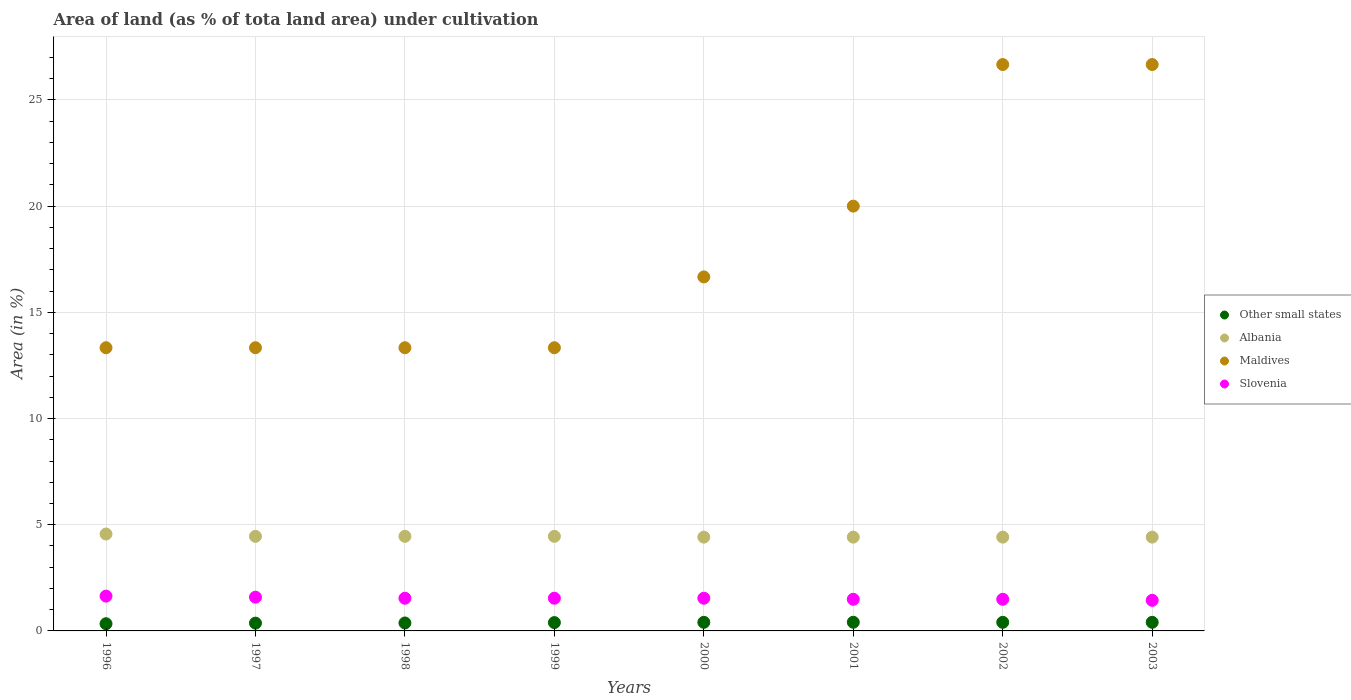Is the number of dotlines equal to the number of legend labels?
Provide a succinct answer. Yes. What is the percentage of land under cultivation in Albania in 1998?
Keep it short and to the point. 4.45. Across all years, what is the maximum percentage of land under cultivation in Slovenia?
Offer a very short reply. 1.64. Across all years, what is the minimum percentage of land under cultivation in Maldives?
Your answer should be compact. 13.33. In which year was the percentage of land under cultivation in Slovenia maximum?
Make the answer very short. 1996. In which year was the percentage of land under cultivation in Slovenia minimum?
Your answer should be very brief. 2003. What is the total percentage of land under cultivation in Maldives in the graph?
Make the answer very short. 143.33. What is the difference between the percentage of land under cultivation in Maldives in 2002 and the percentage of land under cultivation in Albania in 2001?
Make the answer very short. 22.25. What is the average percentage of land under cultivation in Albania per year?
Your answer should be very brief. 4.45. In the year 2003, what is the difference between the percentage of land under cultivation in Albania and percentage of land under cultivation in Other small states?
Give a very brief answer. 4.01. In how many years, is the percentage of land under cultivation in Other small states greater than 13 %?
Offer a very short reply. 0. What is the ratio of the percentage of land under cultivation in Maldives in 2000 to that in 2002?
Keep it short and to the point. 0.63. Is the difference between the percentage of land under cultivation in Albania in 1996 and 2003 greater than the difference between the percentage of land under cultivation in Other small states in 1996 and 2003?
Offer a very short reply. Yes. What is the difference between the highest and the second highest percentage of land under cultivation in Maldives?
Provide a succinct answer. 0. What is the difference between the highest and the lowest percentage of land under cultivation in Slovenia?
Give a very brief answer. 0.2. In how many years, is the percentage of land under cultivation in Maldives greater than the average percentage of land under cultivation in Maldives taken over all years?
Offer a very short reply. 3. Is it the case that in every year, the sum of the percentage of land under cultivation in Other small states and percentage of land under cultivation in Maldives  is greater than the sum of percentage of land under cultivation in Albania and percentage of land under cultivation in Slovenia?
Keep it short and to the point. Yes. Is the percentage of land under cultivation in Other small states strictly less than the percentage of land under cultivation in Maldives over the years?
Offer a terse response. Yes. What is the difference between two consecutive major ticks on the Y-axis?
Ensure brevity in your answer.  5. How many legend labels are there?
Your answer should be compact. 4. What is the title of the graph?
Your response must be concise. Area of land (as % of tota land area) under cultivation. What is the label or title of the Y-axis?
Keep it short and to the point. Area (in %). What is the Area (in %) of Other small states in 1996?
Your answer should be very brief. 0.34. What is the Area (in %) in Albania in 1996?
Offer a very short reply. 4.56. What is the Area (in %) of Maldives in 1996?
Provide a succinct answer. 13.33. What is the Area (in %) in Slovenia in 1996?
Keep it short and to the point. 1.64. What is the Area (in %) in Other small states in 1997?
Provide a succinct answer. 0.37. What is the Area (in %) of Albania in 1997?
Make the answer very short. 4.45. What is the Area (in %) in Maldives in 1997?
Give a very brief answer. 13.33. What is the Area (in %) in Slovenia in 1997?
Make the answer very short. 1.59. What is the Area (in %) of Other small states in 1998?
Keep it short and to the point. 0.37. What is the Area (in %) in Albania in 1998?
Make the answer very short. 4.45. What is the Area (in %) of Maldives in 1998?
Provide a succinct answer. 13.33. What is the Area (in %) in Slovenia in 1998?
Your response must be concise. 1.54. What is the Area (in %) in Other small states in 1999?
Your response must be concise. 0.39. What is the Area (in %) of Albania in 1999?
Keep it short and to the point. 4.45. What is the Area (in %) of Maldives in 1999?
Your response must be concise. 13.33. What is the Area (in %) in Slovenia in 1999?
Ensure brevity in your answer.  1.54. What is the Area (in %) in Other small states in 2000?
Your answer should be compact. 0.41. What is the Area (in %) in Albania in 2000?
Provide a short and direct response. 4.42. What is the Area (in %) in Maldives in 2000?
Give a very brief answer. 16.67. What is the Area (in %) in Slovenia in 2000?
Your answer should be compact. 1.54. What is the Area (in %) in Other small states in 2001?
Your answer should be compact. 0.41. What is the Area (in %) in Albania in 2001?
Make the answer very short. 4.42. What is the Area (in %) of Maldives in 2001?
Ensure brevity in your answer.  20. What is the Area (in %) in Slovenia in 2001?
Provide a short and direct response. 1.49. What is the Area (in %) of Other small states in 2002?
Give a very brief answer. 0.4. What is the Area (in %) of Albania in 2002?
Your answer should be compact. 4.42. What is the Area (in %) in Maldives in 2002?
Make the answer very short. 26.67. What is the Area (in %) of Slovenia in 2002?
Offer a very short reply. 1.49. What is the Area (in %) in Other small states in 2003?
Your response must be concise. 0.41. What is the Area (in %) in Albania in 2003?
Provide a short and direct response. 4.42. What is the Area (in %) in Maldives in 2003?
Provide a succinct answer. 26.67. What is the Area (in %) of Slovenia in 2003?
Provide a succinct answer. 1.44. Across all years, what is the maximum Area (in %) of Other small states?
Offer a terse response. 0.41. Across all years, what is the maximum Area (in %) of Albania?
Keep it short and to the point. 4.56. Across all years, what is the maximum Area (in %) in Maldives?
Your response must be concise. 26.67. Across all years, what is the maximum Area (in %) of Slovenia?
Ensure brevity in your answer.  1.64. Across all years, what is the minimum Area (in %) of Other small states?
Ensure brevity in your answer.  0.34. Across all years, what is the minimum Area (in %) in Albania?
Provide a short and direct response. 4.42. Across all years, what is the minimum Area (in %) in Maldives?
Offer a very short reply. 13.33. Across all years, what is the minimum Area (in %) of Slovenia?
Your response must be concise. 1.44. What is the total Area (in %) in Other small states in the graph?
Provide a short and direct response. 3.09. What is the total Area (in %) of Albania in the graph?
Ensure brevity in your answer.  35.58. What is the total Area (in %) in Maldives in the graph?
Make the answer very short. 143.33. What is the total Area (in %) of Slovenia in the graph?
Offer a very short reply. 12.26. What is the difference between the Area (in %) in Other small states in 1996 and that in 1997?
Provide a succinct answer. -0.03. What is the difference between the Area (in %) in Albania in 1996 and that in 1997?
Your answer should be compact. 0.11. What is the difference between the Area (in %) in Slovenia in 1996 and that in 1997?
Provide a short and direct response. 0.05. What is the difference between the Area (in %) in Other small states in 1996 and that in 1998?
Provide a succinct answer. -0.04. What is the difference between the Area (in %) of Albania in 1996 and that in 1998?
Provide a succinct answer. 0.11. What is the difference between the Area (in %) of Maldives in 1996 and that in 1998?
Your answer should be very brief. 0. What is the difference between the Area (in %) in Slovenia in 1996 and that in 1998?
Your answer should be compact. 0.1. What is the difference between the Area (in %) in Other small states in 1996 and that in 1999?
Provide a succinct answer. -0.05. What is the difference between the Area (in %) in Albania in 1996 and that in 1999?
Your answer should be compact. 0.11. What is the difference between the Area (in %) in Maldives in 1996 and that in 1999?
Keep it short and to the point. 0. What is the difference between the Area (in %) in Slovenia in 1996 and that in 1999?
Make the answer very short. 0.1. What is the difference between the Area (in %) in Other small states in 1996 and that in 2000?
Keep it short and to the point. -0.07. What is the difference between the Area (in %) of Albania in 1996 and that in 2000?
Make the answer very short. 0.15. What is the difference between the Area (in %) in Maldives in 1996 and that in 2000?
Your answer should be very brief. -3.33. What is the difference between the Area (in %) of Slovenia in 1996 and that in 2000?
Offer a very short reply. 0.1. What is the difference between the Area (in %) in Other small states in 1996 and that in 2001?
Offer a terse response. -0.07. What is the difference between the Area (in %) of Albania in 1996 and that in 2001?
Make the answer very short. 0.15. What is the difference between the Area (in %) of Maldives in 1996 and that in 2001?
Your answer should be compact. -6.67. What is the difference between the Area (in %) of Slovenia in 1996 and that in 2001?
Offer a very short reply. 0.15. What is the difference between the Area (in %) of Other small states in 1996 and that in 2002?
Offer a very short reply. -0.07. What is the difference between the Area (in %) in Albania in 1996 and that in 2002?
Offer a terse response. 0.15. What is the difference between the Area (in %) of Maldives in 1996 and that in 2002?
Your answer should be compact. -13.33. What is the difference between the Area (in %) in Slovenia in 1996 and that in 2002?
Give a very brief answer. 0.15. What is the difference between the Area (in %) in Other small states in 1996 and that in 2003?
Your response must be concise. -0.07. What is the difference between the Area (in %) of Albania in 1996 and that in 2003?
Your answer should be compact. 0.15. What is the difference between the Area (in %) in Maldives in 1996 and that in 2003?
Your answer should be compact. -13.33. What is the difference between the Area (in %) in Slovenia in 1996 and that in 2003?
Your answer should be compact. 0.2. What is the difference between the Area (in %) in Other small states in 1997 and that in 1998?
Your answer should be very brief. -0.01. What is the difference between the Area (in %) of Albania in 1997 and that in 1998?
Make the answer very short. 0. What is the difference between the Area (in %) of Maldives in 1997 and that in 1998?
Your response must be concise. 0. What is the difference between the Area (in %) of Slovenia in 1997 and that in 1998?
Give a very brief answer. 0.05. What is the difference between the Area (in %) of Other small states in 1997 and that in 1999?
Provide a succinct answer. -0.03. What is the difference between the Area (in %) in Albania in 1997 and that in 1999?
Make the answer very short. 0. What is the difference between the Area (in %) in Maldives in 1997 and that in 1999?
Your response must be concise. 0. What is the difference between the Area (in %) of Slovenia in 1997 and that in 1999?
Ensure brevity in your answer.  0.05. What is the difference between the Area (in %) of Other small states in 1997 and that in 2000?
Give a very brief answer. -0.04. What is the difference between the Area (in %) in Albania in 1997 and that in 2000?
Your response must be concise. 0.04. What is the difference between the Area (in %) of Maldives in 1997 and that in 2000?
Your answer should be very brief. -3.33. What is the difference between the Area (in %) in Slovenia in 1997 and that in 2000?
Your answer should be very brief. 0.05. What is the difference between the Area (in %) in Other small states in 1997 and that in 2001?
Your response must be concise. -0.04. What is the difference between the Area (in %) of Albania in 1997 and that in 2001?
Your answer should be very brief. 0.04. What is the difference between the Area (in %) in Maldives in 1997 and that in 2001?
Offer a terse response. -6.67. What is the difference between the Area (in %) of Slovenia in 1997 and that in 2001?
Your answer should be very brief. 0.1. What is the difference between the Area (in %) in Other small states in 1997 and that in 2002?
Provide a succinct answer. -0.04. What is the difference between the Area (in %) in Albania in 1997 and that in 2002?
Ensure brevity in your answer.  0.04. What is the difference between the Area (in %) in Maldives in 1997 and that in 2002?
Keep it short and to the point. -13.33. What is the difference between the Area (in %) in Slovenia in 1997 and that in 2002?
Ensure brevity in your answer.  0.1. What is the difference between the Area (in %) of Other small states in 1997 and that in 2003?
Your answer should be compact. -0.04. What is the difference between the Area (in %) of Albania in 1997 and that in 2003?
Ensure brevity in your answer.  0.04. What is the difference between the Area (in %) in Maldives in 1997 and that in 2003?
Your response must be concise. -13.33. What is the difference between the Area (in %) of Slovenia in 1997 and that in 2003?
Your answer should be very brief. 0.15. What is the difference between the Area (in %) of Other small states in 1998 and that in 1999?
Provide a short and direct response. -0.02. What is the difference between the Area (in %) in Albania in 1998 and that in 1999?
Your answer should be compact. 0. What is the difference between the Area (in %) in Slovenia in 1998 and that in 1999?
Your answer should be compact. 0. What is the difference between the Area (in %) in Other small states in 1998 and that in 2000?
Make the answer very short. -0.03. What is the difference between the Area (in %) in Albania in 1998 and that in 2000?
Offer a very short reply. 0.04. What is the difference between the Area (in %) in Other small states in 1998 and that in 2001?
Provide a succinct answer. -0.03. What is the difference between the Area (in %) of Albania in 1998 and that in 2001?
Provide a succinct answer. 0.04. What is the difference between the Area (in %) of Maldives in 1998 and that in 2001?
Offer a terse response. -6.67. What is the difference between the Area (in %) of Slovenia in 1998 and that in 2001?
Make the answer very short. 0.05. What is the difference between the Area (in %) in Other small states in 1998 and that in 2002?
Your response must be concise. -0.03. What is the difference between the Area (in %) in Albania in 1998 and that in 2002?
Keep it short and to the point. 0.04. What is the difference between the Area (in %) of Maldives in 1998 and that in 2002?
Your response must be concise. -13.33. What is the difference between the Area (in %) in Slovenia in 1998 and that in 2002?
Offer a very short reply. 0.05. What is the difference between the Area (in %) in Other small states in 1998 and that in 2003?
Your response must be concise. -0.03. What is the difference between the Area (in %) of Albania in 1998 and that in 2003?
Make the answer very short. 0.04. What is the difference between the Area (in %) in Maldives in 1998 and that in 2003?
Make the answer very short. -13.33. What is the difference between the Area (in %) in Slovenia in 1998 and that in 2003?
Ensure brevity in your answer.  0.1. What is the difference between the Area (in %) of Other small states in 1999 and that in 2000?
Provide a short and direct response. -0.01. What is the difference between the Area (in %) in Albania in 1999 and that in 2000?
Your answer should be very brief. 0.04. What is the difference between the Area (in %) in Maldives in 1999 and that in 2000?
Your answer should be compact. -3.33. What is the difference between the Area (in %) in Slovenia in 1999 and that in 2000?
Ensure brevity in your answer.  0. What is the difference between the Area (in %) in Other small states in 1999 and that in 2001?
Provide a succinct answer. -0.02. What is the difference between the Area (in %) of Albania in 1999 and that in 2001?
Make the answer very short. 0.04. What is the difference between the Area (in %) in Maldives in 1999 and that in 2001?
Offer a very short reply. -6.67. What is the difference between the Area (in %) of Slovenia in 1999 and that in 2001?
Offer a very short reply. 0.05. What is the difference between the Area (in %) of Other small states in 1999 and that in 2002?
Offer a terse response. -0.01. What is the difference between the Area (in %) of Albania in 1999 and that in 2002?
Give a very brief answer. 0.04. What is the difference between the Area (in %) of Maldives in 1999 and that in 2002?
Offer a very short reply. -13.33. What is the difference between the Area (in %) of Slovenia in 1999 and that in 2002?
Keep it short and to the point. 0.05. What is the difference between the Area (in %) of Other small states in 1999 and that in 2003?
Your answer should be compact. -0.01. What is the difference between the Area (in %) in Albania in 1999 and that in 2003?
Your answer should be very brief. 0.04. What is the difference between the Area (in %) of Maldives in 1999 and that in 2003?
Your response must be concise. -13.33. What is the difference between the Area (in %) in Slovenia in 1999 and that in 2003?
Make the answer very short. 0.1. What is the difference between the Area (in %) of Other small states in 2000 and that in 2001?
Offer a very short reply. -0. What is the difference between the Area (in %) in Albania in 2000 and that in 2001?
Provide a succinct answer. 0. What is the difference between the Area (in %) of Slovenia in 2000 and that in 2001?
Your response must be concise. 0.05. What is the difference between the Area (in %) of Other small states in 2000 and that in 2002?
Provide a succinct answer. 0. What is the difference between the Area (in %) in Maldives in 2000 and that in 2002?
Make the answer very short. -10. What is the difference between the Area (in %) of Slovenia in 2000 and that in 2002?
Your answer should be very brief. 0.05. What is the difference between the Area (in %) of Slovenia in 2000 and that in 2003?
Keep it short and to the point. 0.1. What is the difference between the Area (in %) in Other small states in 2001 and that in 2002?
Provide a succinct answer. 0. What is the difference between the Area (in %) in Albania in 2001 and that in 2002?
Make the answer very short. 0. What is the difference between the Area (in %) in Maldives in 2001 and that in 2002?
Your answer should be very brief. -6.67. What is the difference between the Area (in %) in Other small states in 2001 and that in 2003?
Keep it short and to the point. 0. What is the difference between the Area (in %) of Maldives in 2001 and that in 2003?
Offer a very short reply. -6.67. What is the difference between the Area (in %) in Slovenia in 2001 and that in 2003?
Your answer should be compact. 0.05. What is the difference between the Area (in %) in Other small states in 2002 and that in 2003?
Your response must be concise. -0. What is the difference between the Area (in %) of Slovenia in 2002 and that in 2003?
Offer a very short reply. 0.05. What is the difference between the Area (in %) of Other small states in 1996 and the Area (in %) of Albania in 1997?
Offer a terse response. -4.11. What is the difference between the Area (in %) of Other small states in 1996 and the Area (in %) of Maldives in 1997?
Your answer should be very brief. -12.99. What is the difference between the Area (in %) in Other small states in 1996 and the Area (in %) in Slovenia in 1997?
Keep it short and to the point. -1.25. What is the difference between the Area (in %) in Albania in 1996 and the Area (in %) in Maldives in 1997?
Your answer should be compact. -8.77. What is the difference between the Area (in %) in Albania in 1996 and the Area (in %) in Slovenia in 1997?
Give a very brief answer. 2.97. What is the difference between the Area (in %) in Maldives in 1996 and the Area (in %) in Slovenia in 1997?
Make the answer very short. 11.74. What is the difference between the Area (in %) in Other small states in 1996 and the Area (in %) in Albania in 1998?
Provide a succinct answer. -4.11. What is the difference between the Area (in %) in Other small states in 1996 and the Area (in %) in Maldives in 1998?
Ensure brevity in your answer.  -12.99. What is the difference between the Area (in %) of Other small states in 1996 and the Area (in %) of Slovenia in 1998?
Offer a terse response. -1.2. What is the difference between the Area (in %) in Albania in 1996 and the Area (in %) in Maldives in 1998?
Keep it short and to the point. -8.77. What is the difference between the Area (in %) in Albania in 1996 and the Area (in %) in Slovenia in 1998?
Give a very brief answer. 3.02. What is the difference between the Area (in %) in Maldives in 1996 and the Area (in %) in Slovenia in 1998?
Offer a very short reply. 11.79. What is the difference between the Area (in %) in Other small states in 1996 and the Area (in %) in Albania in 1999?
Offer a terse response. -4.11. What is the difference between the Area (in %) of Other small states in 1996 and the Area (in %) of Maldives in 1999?
Provide a succinct answer. -12.99. What is the difference between the Area (in %) of Other small states in 1996 and the Area (in %) of Slovenia in 1999?
Offer a terse response. -1.2. What is the difference between the Area (in %) of Albania in 1996 and the Area (in %) of Maldives in 1999?
Provide a short and direct response. -8.77. What is the difference between the Area (in %) in Albania in 1996 and the Area (in %) in Slovenia in 1999?
Provide a succinct answer. 3.02. What is the difference between the Area (in %) of Maldives in 1996 and the Area (in %) of Slovenia in 1999?
Keep it short and to the point. 11.79. What is the difference between the Area (in %) in Other small states in 1996 and the Area (in %) in Albania in 2000?
Keep it short and to the point. -4.08. What is the difference between the Area (in %) of Other small states in 1996 and the Area (in %) of Maldives in 2000?
Your response must be concise. -16.33. What is the difference between the Area (in %) in Other small states in 1996 and the Area (in %) in Slovenia in 2000?
Offer a terse response. -1.2. What is the difference between the Area (in %) in Albania in 1996 and the Area (in %) in Maldives in 2000?
Ensure brevity in your answer.  -12.1. What is the difference between the Area (in %) of Albania in 1996 and the Area (in %) of Slovenia in 2000?
Give a very brief answer. 3.02. What is the difference between the Area (in %) in Maldives in 1996 and the Area (in %) in Slovenia in 2000?
Offer a terse response. 11.79. What is the difference between the Area (in %) of Other small states in 1996 and the Area (in %) of Albania in 2001?
Make the answer very short. -4.08. What is the difference between the Area (in %) of Other small states in 1996 and the Area (in %) of Maldives in 2001?
Offer a terse response. -19.66. What is the difference between the Area (in %) in Other small states in 1996 and the Area (in %) in Slovenia in 2001?
Your response must be concise. -1.15. What is the difference between the Area (in %) in Albania in 1996 and the Area (in %) in Maldives in 2001?
Give a very brief answer. -15.44. What is the difference between the Area (in %) in Albania in 1996 and the Area (in %) in Slovenia in 2001?
Make the answer very short. 3.07. What is the difference between the Area (in %) in Maldives in 1996 and the Area (in %) in Slovenia in 2001?
Your response must be concise. 11.84. What is the difference between the Area (in %) of Other small states in 1996 and the Area (in %) of Albania in 2002?
Your response must be concise. -4.08. What is the difference between the Area (in %) of Other small states in 1996 and the Area (in %) of Maldives in 2002?
Ensure brevity in your answer.  -26.33. What is the difference between the Area (in %) in Other small states in 1996 and the Area (in %) in Slovenia in 2002?
Give a very brief answer. -1.15. What is the difference between the Area (in %) of Albania in 1996 and the Area (in %) of Maldives in 2002?
Your answer should be compact. -22.1. What is the difference between the Area (in %) in Albania in 1996 and the Area (in %) in Slovenia in 2002?
Offer a very short reply. 3.07. What is the difference between the Area (in %) in Maldives in 1996 and the Area (in %) in Slovenia in 2002?
Your answer should be very brief. 11.84. What is the difference between the Area (in %) of Other small states in 1996 and the Area (in %) of Albania in 2003?
Offer a terse response. -4.08. What is the difference between the Area (in %) in Other small states in 1996 and the Area (in %) in Maldives in 2003?
Ensure brevity in your answer.  -26.33. What is the difference between the Area (in %) of Other small states in 1996 and the Area (in %) of Slovenia in 2003?
Ensure brevity in your answer.  -1.1. What is the difference between the Area (in %) in Albania in 1996 and the Area (in %) in Maldives in 2003?
Your response must be concise. -22.1. What is the difference between the Area (in %) of Albania in 1996 and the Area (in %) of Slovenia in 2003?
Offer a very short reply. 3.12. What is the difference between the Area (in %) in Maldives in 1996 and the Area (in %) in Slovenia in 2003?
Your answer should be very brief. 11.89. What is the difference between the Area (in %) in Other small states in 1997 and the Area (in %) in Albania in 1998?
Give a very brief answer. -4.09. What is the difference between the Area (in %) in Other small states in 1997 and the Area (in %) in Maldives in 1998?
Offer a very short reply. -12.97. What is the difference between the Area (in %) of Other small states in 1997 and the Area (in %) of Slovenia in 1998?
Your response must be concise. -1.17. What is the difference between the Area (in %) in Albania in 1997 and the Area (in %) in Maldives in 1998?
Give a very brief answer. -8.88. What is the difference between the Area (in %) in Albania in 1997 and the Area (in %) in Slovenia in 1998?
Provide a succinct answer. 2.91. What is the difference between the Area (in %) of Maldives in 1997 and the Area (in %) of Slovenia in 1998?
Ensure brevity in your answer.  11.79. What is the difference between the Area (in %) of Other small states in 1997 and the Area (in %) of Albania in 1999?
Your response must be concise. -4.09. What is the difference between the Area (in %) in Other small states in 1997 and the Area (in %) in Maldives in 1999?
Keep it short and to the point. -12.97. What is the difference between the Area (in %) of Other small states in 1997 and the Area (in %) of Slovenia in 1999?
Your answer should be very brief. -1.17. What is the difference between the Area (in %) in Albania in 1997 and the Area (in %) in Maldives in 1999?
Provide a short and direct response. -8.88. What is the difference between the Area (in %) of Albania in 1997 and the Area (in %) of Slovenia in 1999?
Your answer should be very brief. 2.91. What is the difference between the Area (in %) in Maldives in 1997 and the Area (in %) in Slovenia in 1999?
Offer a terse response. 11.79. What is the difference between the Area (in %) in Other small states in 1997 and the Area (in %) in Albania in 2000?
Offer a very short reply. -4.05. What is the difference between the Area (in %) of Other small states in 1997 and the Area (in %) of Maldives in 2000?
Offer a very short reply. -16.3. What is the difference between the Area (in %) in Other small states in 1997 and the Area (in %) in Slovenia in 2000?
Make the answer very short. -1.17. What is the difference between the Area (in %) in Albania in 1997 and the Area (in %) in Maldives in 2000?
Offer a terse response. -12.21. What is the difference between the Area (in %) in Albania in 1997 and the Area (in %) in Slovenia in 2000?
Give a very brief answer. 2.91. What is the difference between the Area (in %) in Maldives in 1997 and the Area (in %) in Slovenia in 2000?
Offer a very short reply. 11.79. What is the difference between the Area (in %) of Other small states in 1997 and the Area (in %) of Albania in 2001?
Offer a very short reply. -4.05. What is the difference between the Area (in %) of Other small states in 1997 and the Area (in %) of Maldives in 2001?
Offer a terse response. -19.63. What is the difference between the Area (in %) of Other small states in 1997 and the Area (in %) of Slovenia in 2001?
Make the answer very short. -1.12. What is the difference between the Area (in %) in Albania in 1997 and the Area (in %) in Maldives in 2001?
Offer a very short reply. -15.55. What is the difference between the Area (in %) of Albania in 1997 and the Area (in %) of Slovenia in 2001?
Your answer should be compact. 2.96. What is the difference between the Area (in %) of Maldives in 1997 and the Area (in %) of Slovenia in 2001?
Offer a terse response. 11.84. What is the difference between the Area (in %) in Other small states in 1997 and the Area (in %) in Albania in 2002?
Keep it short and to the point. -4.05. What is the difference between the Area (in %) of Other small states in 1997 and the Area (in %) of Maldives in 2002?
Your response must be concise. -26.3. What is the difference between the Area (in %) of Other small states in 1997 and the Area (in %) of Slovenia in 2002?
Your answer should be compact. -1.12. What is the difference between the Area (in %) of Albania in 1997 and the Area (in %) of Maldives in 2002?
Keep it short and to the point. -22.21. What is the difference between the Area (in %) of Albania in 1997 and the Area (in %) of Slovenia in 2002?
Your answer should be very brief. 2.96. What is the difference between the Area (in %) of Maldives in 1997 and the Area (in %) of Slovenia in 2002?
Keep it short and to the point. 11.84. What is the difference between the Area (in %) in Other small states in 1997 and the Area (in %) in Albania in 2003?
Keep it short and to the point. -4.05. What is the difference between the Area (in %) of Other small states in 1997 and the Area (in %) of Maldives in 2003?
Your answer should be compact. -26.3. What is the difference between the Area (in %) in Other small states in 1997 and the Area (in %) in Slovenia in 2003?
Offer a terse response. -1.07. What is the difference between the Area (in %) in Albania in 1997 and the Area (in %) in Maldives in 2003?
Make the answer very short. -22.21. What is the difference between the Area (in %) of Albania in 1997 and the Area (in %) of Slovenia in 2003?
Your answer should be compact. 3.01. What is the difference between the Area (in %) of Maldives in 1997 and the Area (in %) of Slovenia in 2003?
Offer a very short reply. 11.89. What is the difference between the Area (in %) of Other small states in 1998 and the Area (in %) of Albania in 1999?
Provide a short and direct response. -4.08. What is the difference between the Area (in %) in Other small states in 1998 and the Area (in %) in Maldives in 1999?
Offer a terse response. -12.96. What is the difference between the Area (in %) in Other small states in 1998 and the Area (in %) in Slovenia in 1999?
Provide a short and direct response. -1.17. What is the difference between the Area (in %) of Albania in 1998 and the Area (in %) of Maldives in 1999?
Offer a terse response. -8.88. What is the difference between the Area (in %) in Albania in 1998 and the Area (in %) in Slovenia in 1999?
Make the answer very short. 2.91. What is the difference between the Area (in %) of Maldives in 1998 and the Area (in %) of Slovenia in 1999?
Provide a succinct answer. 11.79. What is the difference between the Area (in %) in Other small states in 1998 and the Area (in %) in Albania in 2000?
Your response must be concise. -4.04. What is the difference between the Area (in %) of Other small states in 1998 and the Area (in %) of Maldives in 2000?
Keep it short and to the point. -16.29. What is the difference between the Area (in %) in Other small states in 1998 and the Area (in %) in Slovenia in 2000?
Ensure brevity in your answer.  -1.17. What is the difference between the Area (in %) in Albania in 1998 and the Area (in %) in Maldives in 2000?
Your response must be concise. -12.21. What is the difference between the Area (in %) in Albania in 1998 and the Area (in %) in Slovenia in 2000?
Your answer should be compact. 2.91. What is the difference between the Area (in %) of Maldives in 1998 and the Area (in %) of Slovenia in 2000?
Provide a short and direct response. 11.79. What is the difference between the Area (in %) of Other small states in 1998 and the Area (in %) of Albania in 2001?
Offer a terse response. -4.04. What is the difference between the Area (in %) of Other small states in 1998 and the Area (in %) of Maldives in 2001?
Your answer should be very brief. -19.63. What is the difference between the Area (in %) in Other small states in 1998 and the Area (in %) in Slovenia in 2001?
Offer a terse response. -1.12. What is the difference between the Area (in %) of Albania in 1998 and the Area (in %) of Maldives in 2001?
Offer a very short reply. -15.55. What is the difference between the Area (in %) in Albania in 1998 and the Area (in %) in Slovenia in 2001?
Keep it short and to the point. 2.96. What is the difference between the Area (in %) of Maldives in 1998 and the Area (in %) of Slovenia in 2001?
Provide a short and direct response. 11.84. What is the difference between the Area (in %) in Other small states in 1998 and the Area (in %) in Albania in 2002?
Provide a succinct answer. -4.04. What is the difference between the Area (in %) in Other small states in 1998 and the Area (in %) in Maldives in 2002?
Ensure brevity in your answer.  -26.29. What is the difference between the Area (in %) in Other small states in 1998 and the Area (in %) in Slovenia in 2002?
Your answer should be compact. -1.12. What is the difference between the Area (in %) of Albania in 1998 and the Area (in %) of Maldives in 2002?
Your answer should be very brief. -22.21. What is the difference between the Area (in %) of Albania in 1998 and the Area (in %) of Slovenia in 2002?
Ensure brevity in your answer.  2.96. What is the difference between the Area (in %) of Maldives in 1998 and the Area (in %) of Slovenia in 2002?
Make the answer very short. 11.84. What is the difference between the Area (in %) of Other small states in 1998 and the Area (in %) of Albania in 2003?
Your answer should be compact. -4.04. What is the difference between the Area (in %) of Other small states in 1998 and the Area (in %) of Maldives in 2003?
Your answer should be very brief. -26.29. What is the difference between the Area (in %) of Other small states in 1998 and the Area (in %) of Slovenia in 2003?
Your answer should be very brief. -1.07. What is the difference between the Area (in %) in Albania in 1998 and the Area (in %) in Maldives in 2003?
Provide a succinct answer. -22.21. What is the difference between the Area (in %) of Albania in 1998 and the Area (in %) of Slovenia in 2003?
Your answer should be compact. 3.01. What is the difference between the Area (in %) in Maldives in 1998 and the Area (in %) in Slovenia in 2003?
Keep it short and to the point. 11.89. What is the difference between the Area (in %) in Other small states in 1999 and the Area (in %) in Albania in 2000?
Keep it short and to the point. -4.02. What is the difference between the Area (in %) of Other small states in 1999 and the Area (in %) of Maldives in 2000?
Provide a short and direct response. -16.27. What is the difference between the Area (in %) in Other small states in 1999 and the Area (in %) in Slovenia in 2000?
Ensure brevity in your answer.  -1.15. What is the difference between the Area (in %) in Albania in 1999 and the Area (in %) in Maldives in 2000?
Give a very brief answer. -12.21. What is the difference between the Area (in %) of Albania in 1999 and the Area (in %) of Slovenia in 2000?
Offer a very short reply. 2.91. What is the difference between the Area (in %) in Maldives in 1999 and the Area (in %) in Slovenia in 2000?
Give a very brief answer. 11.79. What is the difference between the Area (in %) in Other small states in 1999 and the Area (in %) in Albania in 2001?
Offer a terse response. -4.02. What is the difference between the Area (in %) of Other small states in 1999 and the Area (in %) of Maldives in 2001?
Provide a short and direct response. -19.61. What is the difference between the Area (in %) of Other small states in 1999 and the Area (in %) of Slovenia in 2001?
Your response must be concise. -1.1. What is the difference between the Area (in %) of Albania in 1999 and the Area (in %) of Maldives in 2001?
Ensure brevity in your answer.  -15.55. What is the difference between the Area (in %) of Albania in 1999 and the Area (in %) of Slovenia in 2001?
Keep it short and to the point. 2.96. What is the difference between the Area (in %) in Maldives in 1999 and the Area (in %) in Slovenia in 2001?
Your answer should be compact. 11.84. What is the difference between the Area (in %) of Other small states in 1999 and the Area (in %) of Albania in 2002?
Provide a succinct answer. -4.02. What is the difference between the Area (in %) of Other small states in 1999 and the Area (in %) of Maldives in 2002?
Keep it short and to the point. -26.27. What is the difference between the Area (in %) in Other small states in 1999 and the Area (in %) in Slovenia in 2002?
Offer a terse response. -1.1. What is the difference between the Area (in %) in Albania in 1999 and the Area (in %) in Maldives in 2002?
Your answer should be very brief. -22.21. What is the difference between the Area (in %) of Albania in 1999 and the Area (in %) of Slovenia in 2002?
Give a very brief answer. 2.96. What is the difference between the Area (in %) in Maldives in 1999 and the Area (in %) in Slovenia in 2002?
Keep it short and to the point. 11.84. What is the difference between the Area (in %) in Other small states in 1999 and the Area (in %) in Albania in 2003?
Your answer should be compact. -4.02. What is the difference between the Area (in %) in Other small states in 1999 and the Area (in %) in Maldives in 2003?
Your answer should be very brief. -26.27. What is the difference between the Area (in %) in Other small states in 1999 and the Area (in %) in Slovenia in 2003?
Provide a succinct answer. -1.05. What is the difference between the Area (in %) of Albania in 1999 and the Area (in %) of Maldives in 2003?
Ensure brevity in your answer.  -22.21. What is the difference between the Area (in %) in Albania in 1999 and the Area (in %) in Slovenia in 2003?
Keep it short and to the point. 3.01. What is the difference between the Area (in %) in Maldives in 1999 and the Area (in %) in Slovenia in 2003?
Keep it short and to the point. 11.89. What is the difference between the Area (in %) in Other small states in 2000 and the Area (in %) in Albania in 2001?
Your answer should be very brief. -4.01. What is the difference between the Area (in %) in Other small states in 2000 and the Area (in %) in Maldives in 2001?
Ensure brevity in your answer.  -19.59. What is the difference between the Area (in %) of Other small states in 2000 and the Area (in %) of Slovenia in 2001?
Offer a very short reply. -1.08. What is the difference between the Area (in %) of Albania in 2000 and the Area (in %) of Maldives in 2001?
Ensure brevity in your answer.  -15.58. What is the difference between the Area (in %) of Albania in 2000 and the Area (in %) of Slovenia in 2001?
Provide a short and direct response. 2.93. What is the difference between the Area (in %) in Maldives in 2000 and the Area (in %) in Slovenia in 2001?
Offer a very short reply. 15.18. What is the difference between the Area (in %) in Other small states in 2000 and the Area (in %) in Albania in 2002?
Your answer should be very brief. -4.01. What is the difference between the Area (in %) of Other small states in 2000 and the Area (in %) of Maldives in 2002?
Provide a short and direct response. -26.26. What is the difference between the Area (in %) of Other small states in 2000 and the Area (in %) of Slovenia in 2002?
Offer a very short reply. -1.08. What is the difference between the Area (in %) in Albania in 2000 and the Area (in %) in Maldives in 2002?
Your answer should be compact. -22.25. What is the difference between the Area (in %) of Albania in 2000 and the Area (in %) of Slovenia in 2002?
Offer a very short reply. 2.93. What is the difference between the Area (in %) in Maldives in 2000 and the Area (in %) in Slovenia in 2002?
Offer a very short reply. 15.18. What is the difference between the Area (in %) in Other small states in 2000 and the Area (in %) in Albania in 2003?
Offer a very short reply. -4.01. What is the difference between the Area (in %) of Other small states in 2000 and the Area (in %) of Maldives in 2003?
Keep it short and to the point. -26.26. What is the difference between the Area (in %) in Other small states in 2000 and the Area (in %) in Slovenia in 2003?
Provide a short and direct response. -1.03. What is the difference between the Area (in %) in Albania in 2000 and the Area (in %) in Maldives in 2003?
Ensure brevity in your answer.  -22.25. What is the difference between the Area (in %) of Albania in 2000 and the Area (in %) of Slovenia in 2003?
Your answer should be very brief. 2.98. What is the difference between the Area (in %) in Maldives in 2000 and the Area (in %) in Slovenia in 2003?
Provide a succinct answer. 15.23. What is the difference between the Area (in %) in Other small states in 2001 and the Area (in %) in Albania in 2002?
Give a very brief answer. -4.01. What is the difference between the Area (in %) of Other small states in 2001 and the Area (in %) of Maldives in 2002?
Provide a short and direct response. -26.26. What is the difference between the Area (in %) in Other small states in 2001 and the Area (in %) in Slovenia in 2002?
Your response must be concise. -1.08. What is the difference between the Area (in %) of Albania in 2001 and the Area (in %) of Maldives in 2002?
Provide a succinct answer. -22.25. What is the difference between the Area (in %) in Albania in 2001 and the Area (in %) in Slovenia in 2002?
Provide a short and direct response. 2.93. What is the difference between the Area (in %) in Maldives in 2001 and the Area (in %) in Slovenia in 2002?
Make the answer very short. 18.51. What is the difference between the Area (in %) of Other small states in 2001 and the Area (in %) of Albania in 2003?
Your answer should be very brief. -4.01. What is the difference between the Area (in %) of Other small states in 2001 and the Area (in %) of Maldives in 2003?
Offer a very short reply. -26.26. What is the difference between the Area (in %) of Other small states in 2001 and the Area (in %) of Slovenia in 2003?
Keep it short and to the point. -1.03. What is the difference between the Area (in %) of Albania in 2001 and the Area (in %) of Maldives in 2003?
Make the answer very short. -22.25. What is the difference between the Area (in %) in Albania in 2001 and the Area (in %) in Slovenia in 2003?
Keep it short and to the point. 2.98. What is the difference between the Area (in %) in Maldives in 2001 and the Area (in %) in Slovenia in 2003?
Your answer should be compact. 18.56. What is the difference between the Area (in %) in Other small states in 2002 and the Area (in %) in Albania in 2003?
Offer a very short reply. -4.01. What is the difference between the Area (in %) of Other small states in 2002 and the Area (in %) of Maldives in 2003?
Keep it short and to the point. -26.26. What is the difference between the Area (in %) in Other small states in 2002 and the Area (in %) in Slovenia in 2003?
Keep it short and to the point. -1.04. What is the difference between the Area (in %) of Albania in 2002 and the Area (in %) of Maldives in 2003?
Make the answer very short. -22.25. What is the difference between the Area (in %) of Albania in 2002 and the Area (in %) of Slovenia in 2003?
Offer a terse response. 2.98. What is the difference between the Area (in %) of Maldives in 2002 and the Area (in %) of Slovenia in 2003?
Offer a terse response. 25.23. What is the average Area (in %) in Other small states per year?
Keep it short and to the point. 0.39. What is the average Area (in %) in Albania per year?
Your answer should be compact. 4.45. What is the average Area (in %) in Maldives per year?
Give a very brief answer. 17.92. What is the average Area (in %) in Slovenia per year?
Ensure brevity in your answer.  1.53. In the year 1996, what is the difference between the Area (in %) of Other small states and Area (in %) of Albania?
Offer a terse response. -4.22. In the year 1996, what is the difference between the Area (in %) of Other small states and Area (in %) of Maldives?
Offer a very short reply. -12.99. In the year 1996, what is the difference between the Area (in %) of Other small states and Area (in %) of Slovenia?
Give a very brief answer. -1.3. In the year 1996, what is the difference between the Area (in %) of Albania and Area (in %) of Maldives?
Provide a short and direct response. -8.77. In the year 1996, what is the difference between the Area (in %) of Albania and Area (in %) of Slovenia?
Offer a terse response. 2.92. In the year 1996, what is the difference between the Area (in %) in Maldives and Area (in %) in Slovenia?
Offer a very short reply. 11.69. In the year 1997, what is the difference between the Area (in %) of Other small states and Area (in %) of Albania?
Ensure brevity in your answer.  -4.09. In the year 1997, what is the difference between the Area (in %) in Other small states and Area (in %) in Maldives?
Give a very brief answer. -12.97. In the year 1997, what is the difference between the Area (in %) of Other small states and Area (in %) of Slovenia?
Ensure brevity in your answer.  -1.22. In the year 1997, what is the difference between the Area (in %) of Albania and Area (in %) of Maldives?
Provide a short and direct response. -8.88. In the year 1997, what is the difference between the Area (in %) in Albania and Area (in %) in Slovenia?
Ensure brevity in your answer.  2.86. In the year 1997, what is the difference between the Area (in %) of Maldives and Area (in %) of Slovenia?
Your answer should be compact. 11.74. In the year 1998, what is the difference between the Area (in %) of Other small states and Area (in %) of Albania?
Offer a very short reply. -4.08. In the year 1998, what is the difference between the Area (in %) in Other small states and Area (in %) in Maldives?
Make the answer very short. -12.96. In the year 1998, what is the difference between the Area (in %) in Other small states and Area (in %) in Slovenia?
Make the answer very short. -1.17. In the year 1998, what is the difference between the Area (in %) in Albania and Area (in %) in Maldives?
Provide a succinct answer. -8.88. In the year 1998, what is the difference between the Area (in %) in Albania and Area (in %) in Slovenia?
Your answer should be compact. 2.91. In the year 1998, what is the difference between the Area (in %) in Maldives and Area (in %) in Slovenia?
Your answer should be compact. 11.79. In the year 1999, what is the difference between the Area (in %) in Other small states and Area (in %) in Albania?
Ensure brevity in your answer.  -4.06. In the year 1999, what is the difference between the Area (in %) of Other small states and Area (in %) of Maldives?
Make the answer very short. -12.94. In the year 1999, what is the difference between the Area (in %) in Other small states and Area (in %) in Slovenia?
Make the answer very short. -1.15. In the year 1999, what is the difference between the Area (in %) of Albania and Area (in %) of Maldives?
Your answer should be compact. -8.88. In the year 1999, what is the difference between the Area (in %) of Albania and Area (in %) of Slovenia?
Keep it short and to the point. 2.91. In the year 1999, what is the difference between the Area (in %) of Maldives and Area (in %) of Slovenia?
Offer a very short reply. 11.79. In the year 2000, what is the difference between the Area (in %) of Other small states and Area (in %) of Albania?
Offer a very short reply. -4.01. In the year 2000, what is the difference between the Area (in %) of Other small states and Area (in %) of Maldives?
Offer a very short reply. -16.26. In the year 2000, what is the difference between the Area (in %) of Other small states and Area (in %) of Slovenia?
Ensure brevity in your answer.  -1.13. In the year 2000, what is the difference between the Area (in %) in Albania and Area (in %) in Maldives?
Give a very brief answer. -12.25. In the year 2000, what is the difference between the Area (in %) in Albania and Area (in %) in Slovenia?
Ensure brevity in your answer.  2.88. In the year 2000, what is the difference between the Area (in %) in Maldives and Area (in %) in Slovenia?
Offer a very short reply. 15.13. In the year 2001, what is the difference between the Area (in %) of Other small states and Area (in %) of Albania?
Provide a short and direct response. -4.01. In the year 2001, what is the difference between the Area (in %) of Other small states and Area (in %) of Maldives?
Keep it short and to the point. -19.59. In the year 2001, what is the difference between the Area (in %) in Other small states and Area (in %) in Slovenia?
Ensure brevity in your answer.  -1.08. In the year 2001, what is the difference between the Area (in %) of Albania and Area (in %) of Maldives?
Offer a very short reply. -15.58. In the year 2001, what is the difference between the Area (in %) of Albania and Area (in %) of Slovenia?
Give a very brief answer. 2.93. In the year 2001, what is the difference between the Area (in %) in Maldives and Area (in %) in Slovenia?
Provide a succinct answer. 18.51. In the year 2002, what is the difference between the Area (in %) of Other small states and Area (in %) of Albania?
Your answer should be very brief. -4.01. In the year 2002, what is the difference between the Area (in %) of Other small states and Area (in %) of Maldives?
Provide a short and direct response. -26.26. In the year 2002, what is the difference between the Area (in %) of Other small states and Area (in %) of Slovenia?
Your response must be concise. -1.09. In the year 2002, what is the difference between the Area (in %) in Albania and Area (in %) in Maldives?
Offer a very short reply. -22.25. In the year 2002, what is the difference between the Area (in %) of Albania and Area (in %) of Slovenia?
Make the answer very short. 2.93. In the year 2002, what is the difference between the Area (in %) of Maldives and Area (in %) of Slovenia?
Provide a short and direct response. 25.18. In the year 2003, what is the difference between the Area (in %) in Other small states and Area (in %) in Albania?
Provide a succinct answer. -4.01. In the year 2003, what is the difference between the Area (in %) of Other small states and Area (in %) of Maldives?
Provide a succinct answer. -26.26. In the year 2003, what is the difference between the Area (in %) of Other small states and Area (in %) of Slovenia?
Your response must be concise. -1.03. In the year 2003, what is the difference between the Area (in %) of Albania and Area (in %) of Maldives?
Ensure brevity in your answer.  -22.25. In the year 2003, what is the difference between the Area (in %) in Albania and Area (in %) in Slovenia?
Offer a very short reply. 2.98. In the year 2003, what is the difference between the Area (in %) of Maldives and Area (in %) of Slovenia?
Make the answer very short. 25.23. What is the ratio of the Area (in %) of Other small states in 1996 to that in 1997?
Offer a very short reply. 0.92. What is the ratio of the Area (in %) in Albania in 1996 to that in 1997?
Give a very brief answer. 1.02. What is the ratio of the Area (in %) in Slovenia in 1996 to that in 1997?
Your response must be concise. 1.03. What is the ratio of the Area (in %) of Other small states in 1996 to that in 1998?
Your response must be concise. 0.9. What is the ratio of the Area (in %) of Albania in 1996 to that in 1998?
Keep it short and to the point. 1.02. What is the ratio of the Area (in %) of Maldives in 1996 to that in 1998?
Your response must be concise. 1. What is the ratio of the Area (in %) of Slovenia in 1996 to that in 1998?
Offer a very short reply. 1.06. What is the ratio of the Area (in %) in Other small states in 1996 to that in 1999?
Your response must be concise. 0.86. What is the ratio of the Area (in %) of Albania in 1996 to that in 1999?
Provide a succinct answer. 1.02. What is the ratio of the Area (in %) of Slovenia in 1996 to that in 1999?
Your answer should be compact. 1.06. What is the ratio of the Area (in %) of Other small states in 1996 to that in 2000?
Keep it short and to the point. 0.84. What is the ratio of the Area (in %) of Albania in 1996 to that in 2000?
Your answer should be very brief. 1.03. What is the ratio of the Area (in %) in Maldives in 1996 to that in 2000?
Your answer should be compact. 0.8. What is the ratio of the Area (in %) in Slovenia in 1996 to that in 2000?
Offer a terse response. 1.06. What is the ratio of the Area (in %) in Other small states in 1996 to that in 2001?
Make the answer very short. 0.83. What is the ratio of the Area (in %) of Albania in 1996 to that in 2001?
Provide a succinct answer. 1.03. What is the ratio of the Area (in %) in Other small states in 1996 to that in 2002?
Keep it short and to the point. 0.84. What is the ratio of the Area (in %) in Albania in 1996 to that in 2002?
Ensure brevity in your answer.  1.03. What is the ratio of the Area (in %) of Other small states in 1996 to that in 2003?
Ensure brevity in your answer.  0.84. What is the ratio of the Area (in %) in Albania in 1996 to that in 2003?
Your answer should be compact. 1.03. What is the ratio of the Area (in %) in Maldives in 1996 to that in 2003?
Offer a very short reply. 0.5. What is the ratio of the Area (in %) in Slovenia in 1996 to that in 2003?
Provide a succinct answer. 1.14. What is the ratio of the Area (in %) in Other small states in 1997 to that in 1998?
Your answer should be very brief. 0.98. What is the ratio of the Area (in %) of Slovenia in 1997 to that in 1998?
Make the answer very short. 1.03. What is the ratio of the Area (in %) in Other small states in 1997 to that in 1999?
Your answer should be very brief. 0.94. What is the ratio of the Area (in %) in Albania in 1997 to that in 1999?
Give a very brief answer. 1. What is the ratio of the Area (in %) in Maldives in 1997 to that in 1999?
Your answer should be compact. 1. What is the ratio of the Area (in %) of Slovenia in 1997 to that in 1999?
Your answer should be very brief. 1.03. What is the ratio of the Area (in %) of Other small states in 1997 to that in 2000?
Give a very brief answer. 0.91. What is the ratio of the Area (in %) of Albania in 1997 to that in 2000?
Keep it short and to the point. 1.01. What is the ratio of the Area (in %) of Slovenia in 1997 to that in 2000?
Provide a short and direct response. 1.03. What is the ratio of the Area (in %) of Other small states in 1997 to that in 2001?
Offer a very short reply. 0.9. What is the ratio of the Area (in %) of Albania in 1997 to that in 2001?
Offer a very short reply. 1.01. What is the ratio of the Area (in %) in Maldives in 1997 to that in 2001?
Provide a short and direct response. 0.67. What is the ratio of the Area (in %) of Slovenia in 1997 to that in 2001?
Make the answer very short. 1.07. What is the ratio of the Area (in %) in Other small states in 1997 to that in 2002?
Ensure brevity in your answer.  0.91. What is the ratio of the Area (in %) of Albania in 1997 to that in 2002?
Offer a terse response. 1.01. What is the ratio of the Area (in %) in Slovenia in 1997 to that in 2002?
Offer a very short reply. 1.07. What is the ratio of the Area (in %) in Other small states in 1997 to that in 2003?
Make the answer very short. 0.91. What is the ratio of the Area (in %) in Albania in 1997 to that in 2003?
Your answer should be compact. 1.01. What is the ratio of the Area (in %) of Maldives in 1997 to that in 2003?
Make the answer very short. 0.5. What is the ratio of the Area (in %) in Slovenia in 1997 to that in 2003?
Provide a short and direct response. 1.1. What is the ratio of the Area (in %) in Other small states in 1998 to that in 1999?
Ensure brevity in your answer.  0.95. What is the ratio of the Area (in %) of Albania in 1998 to that in 1999?
Keep it short and to the point. 1. What is the ratio of the Area (in %) in Slovenia in 1998 to that in 1999?
Your answer should be very brief. 1. What is the ratio of the Area (in %) in Other small states in 1998 to that in 2000?
Provide a short and direct response. 0.92. What is the ratio of the Area (in %) in Albania in 1998 to that in 2000?
Your answer should be compact. 1.01. What is the ratio of the Area (in %) in Slovenia in 1998 to that in 2000?
Your answer should be very brief. 1. What is the ratio of the Area (in %) of Other small states in 1998 to that in 2001?
Your answer should be very brief. 0.92. What is the ratio of the Area (in %) in Albania in 1998 to that in 2001?
Give a very brief answer. 1.01. What is the ratio of the Area (in %) of Maldives in 1998 to that in 2001?
Your answer should be compact. 0.67. What is the ratio of the Area (in %) of Other small states in 1998 to that in 2002?
Offer a very short reply. 0.93. What is the ratio of the Area (in %) of Albania in 1998 to that in 2002?
Offer a very short reply. 1.01. What is the ratio of the Area (in %) in Maldives in 1998 to that in 2002?
Ensure brevity in your answer.  0.5. What is the ratio of the Area (in %) in Slovenia in 1998 to that in 2002?
Provide a short and direct response. 1.03. What is the ratio of the Area (in %) in Other small states in 1998 to that in 2003?
Offer a terse response. 0.92. What is the ratio of the Area (in %) of Albania in 1998 to that in 2003?
Give a very brief answer. 1.01. What is the ratio of the Area (in %) in Maldives in 1998 to that in 2003?
Ensure brevity in your answer.  0.5. What is the ratio of the Area (in %) of Slovenia in 1998 to that in 2003?
Your answer should be very brief. 1.07. What is the ratio of the Area (in %) in Other small states in 1999 to that in 2000?
Ensure brevity in your answer.  0.97. What is the ratio of the Area (in %) of Albania in 1999 to that in 2000?
Ensure brevity in your answer.  1.01. What is the ratio of the Area (in %) of Slovenia in 1999 to that in 2000?
Provide a short and direct response. 1. What is the ratio of the Area (in %) in Other small states in 1999 to that in 2001?
Your answer should be very brief. 0.96. What is the ratio of the Area (in %) of Albania in 1999 to that in 2001?
Keep it short and to the point. 1.01. What is the ratio of the Area (in %) in Other small states in 1999 to that in 2002?
Give a very brief answer. 0.97. What is the ratio of the Area (in %) in Albania in 1999 to that in 2002?
Offer a terse response. 1.01. What is the ratio of the Area (in %) of Maldives in 1999 to that in 2002?
Your answer should be very brief. 0.5. What is the ratio of the Area (in %) of Other small states in 1999 to that in 2003?
Ensure brevity in your answer.  0.97. What is the ratio of the Area (in %) in Albania in 1999 to that in 2003?
Give a very brief answer. 1.01. What is the ratio of the Area (in %) in Maldives in 1999 to that in 2003?
Your response must be concise. 0.5. What is the ratio of the Area (in %) in Slovenia in 1999 to that in 2003?
Make the answer very short. 1.07. What is the ratio of the Area (in %) of Other small states in 2000 to that in 2001?
Keep it short and to the point. 0.99. What is the ratio of the Area (in %) of Albania in 2000 to that in 2001?
Provide a short and direct response. 1. What is the ratio of the Area (in %) in Slovenia in 2000 to that in 2001?
Keep it short and to the point. 1.03. What is the ratio of the Area (in %) of Other small states in 2000 to that in 2002?
Ensure brevity in your answer.  1. What is the ratio of the Area (in %) in Albania in 2000 to that in 2002?
Make the answer very short. 1. What is the ratio of the Area (in %) in Maldives in 2000 to that in 2002?
Make the answer very short. 0.62. What is the ratio of the Area (in %) in Slovenia in 2000 to that in 2002?
Keep it short and to the point. 1.03. What is the ratio of the Area (in %) of Maldives in 2000 to that in 2003?
Provide a short and direct response. 0.62. What is the ratio of the Area (in %) of Slovenia in 2000 to that in 2003?
Ensure brevity in your answer.  1.07. What is the ratio of the Area (in %) of Other small states in 2001 to that in 2002?
Keep it short and to the point. 1.01. What is the ratio of the Area (in %) of Albania in 2001 to that in 2002?
Give a very brief answer. 1. What is the ratio of the Area (in %) in Other small states in 2001 to that in 2003?
Ensure brevity in your answer.  1.01. What is the ratio of the Area (in %) in Albania in 2001 to that in 2003?
Keep it short and to the point. 1. What is the ratio of the Area (in %) of Maldives in 2001 to that in 2003?
Ensure brevity in your answer.  0.75. What is the ratio of the Area (in %) in Slovenia in 2001 to that in 2003?
Offer a very short reply. 1.03. What is the ratio of the Area (in %) of Maldives in 2002 to that in 2003?
Keep it short and to the point. 1. What is the ratio of the Area (in %) in Slovenia in 2002 to that in 2003?
Make the answer very short. 1.03. What is the difference between the highest and the second highest Area (in %) in Other small states?
Your response must be concise. 0. What is the difference between the highest and the second highest Area (in %) of Albania?
Provide a short and direct response. 0.11. What is the difference between the highest and the second highest Area (in %) of Maldives?
Make the answer very short. 0. What is the difference between the highest and the second highest Area (in %) in Slovenia?
Offer a terse response. 0.05. What is the difference between the highest and the lowest Area (in %) of Other small states?
Make the answer very short. 0.07. What is the difference between the highest and the lowest Area (in %) of Albania?
Offer a very short reply. 0.15. What is the difference between the highest and the lowest Area (in %) in Maldives?
Your answer should be compact. 13.33. What is the difference between the highest and the lowest Area (in %) in Slovenia?
Keep it short and to the point. 0.2. 